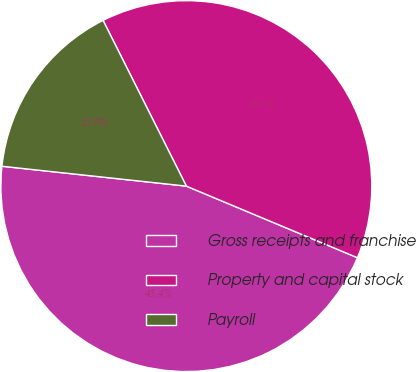Convert chart. <chart><loc_0><loc_0><loc_500><loc_500><pie_chart><fcel>Gross receipts and franchise<fcel>Property and capital stock<fcel>Payroll<nl><fcel>45.4%<fcel>38.72%<fcel>15.88%<nl></chart> 